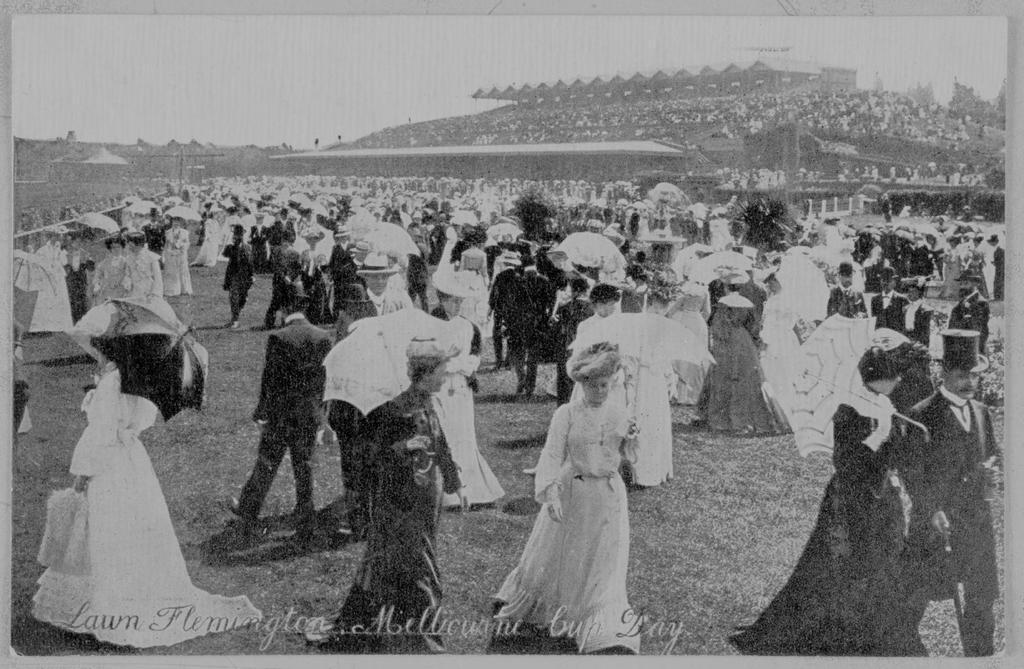Describe this image in one or two sentences. This is a black and white picture. Here we can see crowd and they are holding umbrellas. 